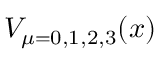<formula> <loc_0><loc_0><loc_500><loc_500>V _ { \mu = 0 , 1 , 2 , 3 } ( x )</formula> 